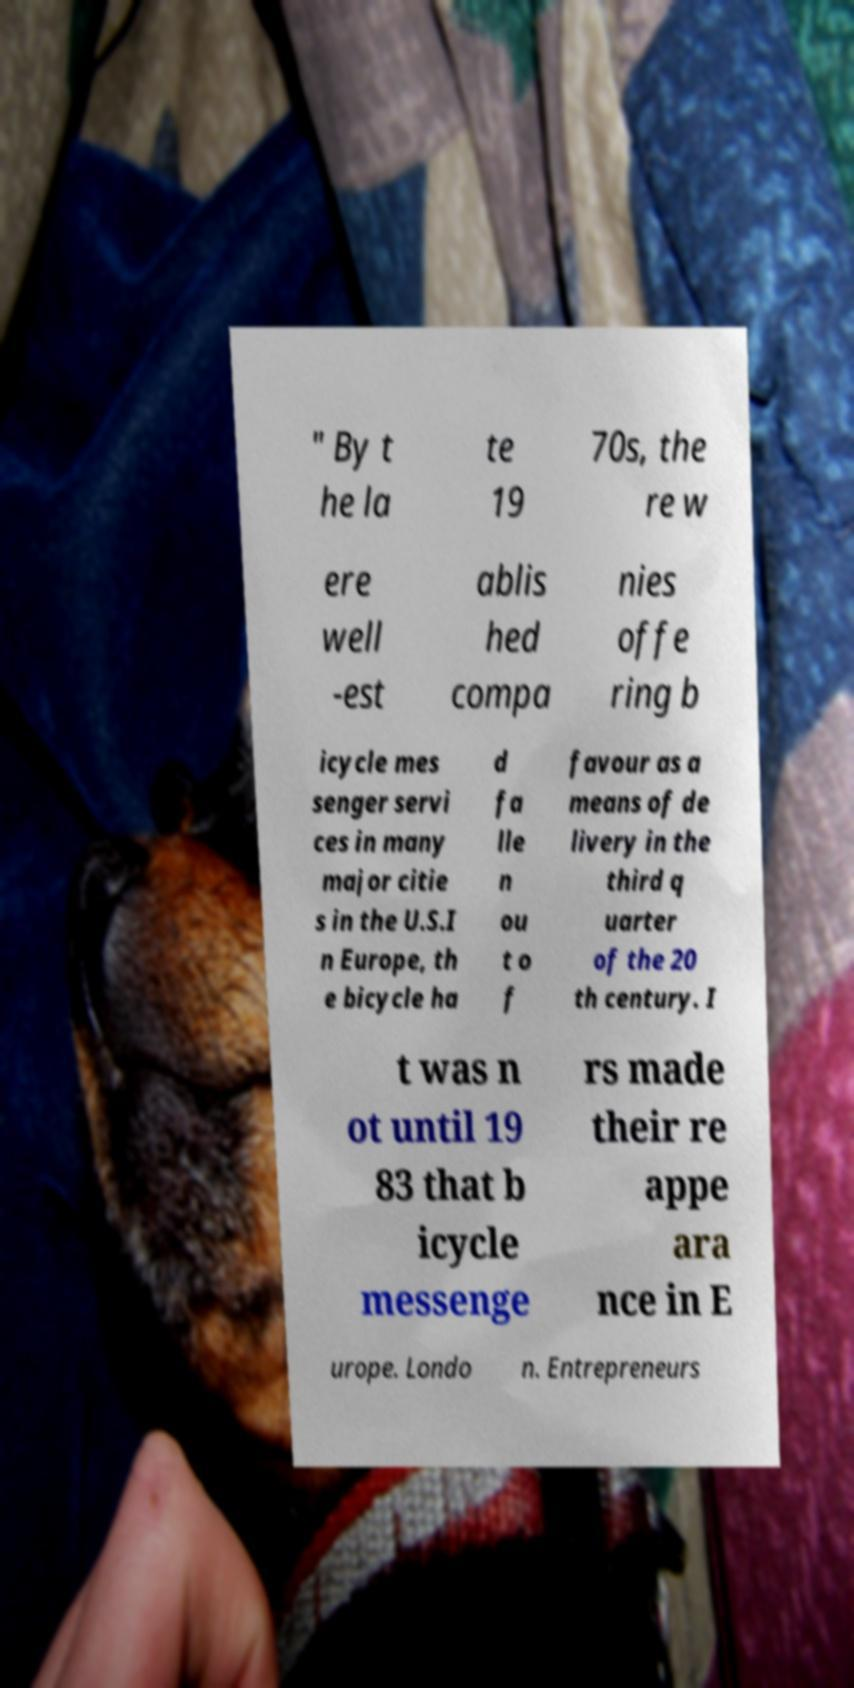Can you accurately transcribe the text from the provided image for me? " By t he la te 19 70s, the re w ere well -est ablis hed compa nies offe ring b icycle mes senger servi ces in many major citie s in the U.S.I n Europe, th e bicycle ha d fa lle n ou t o f favour as a means of de livery in the third q uarter of the 20 th century. I t was n ot until 19 83 that b icycle messenge rs made their re appe ara nce in E urope. Londo n. Entrepreneurs 